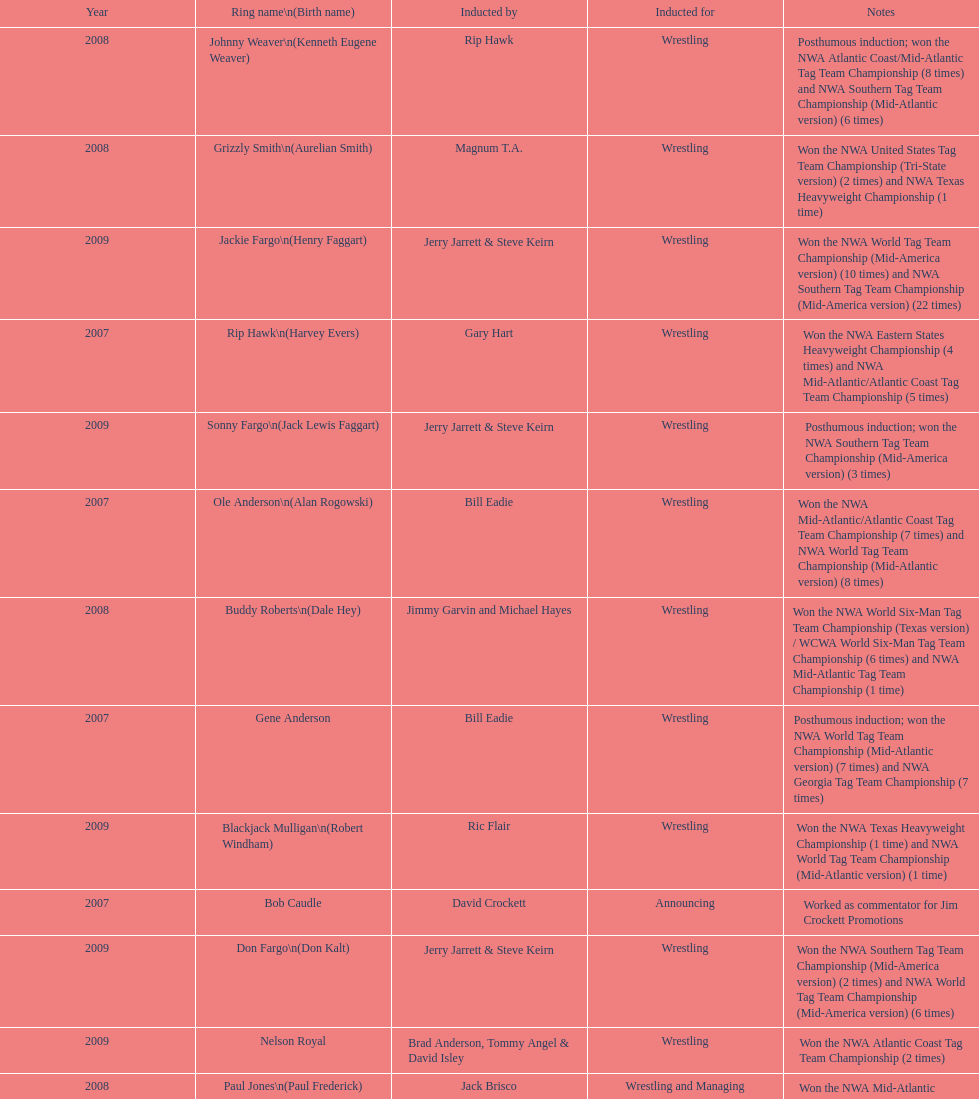What number of members were inducted before 2009? 14. 